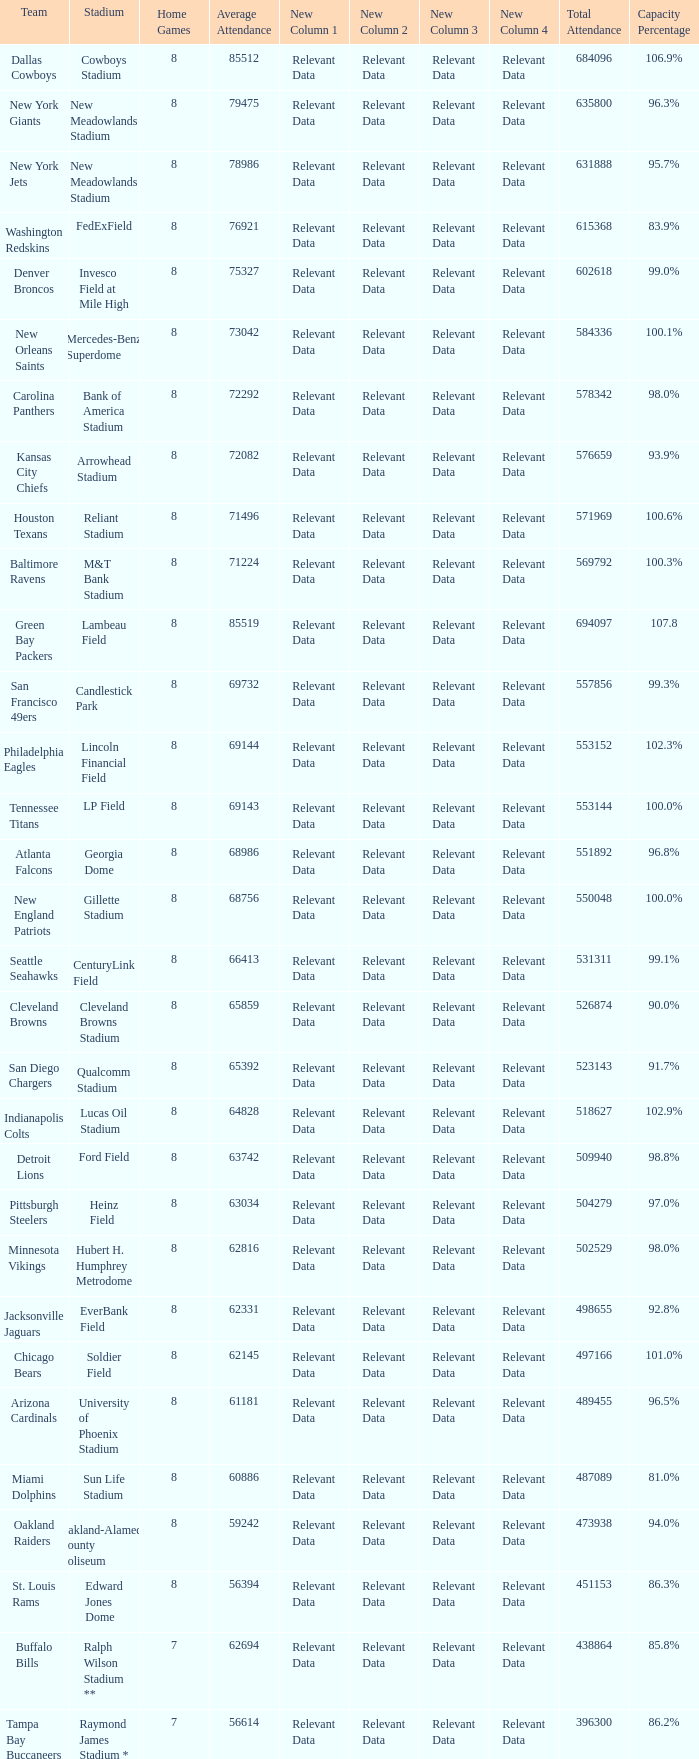What is the name of the stadium when the capacity percentage is 83.9% FedExField. 